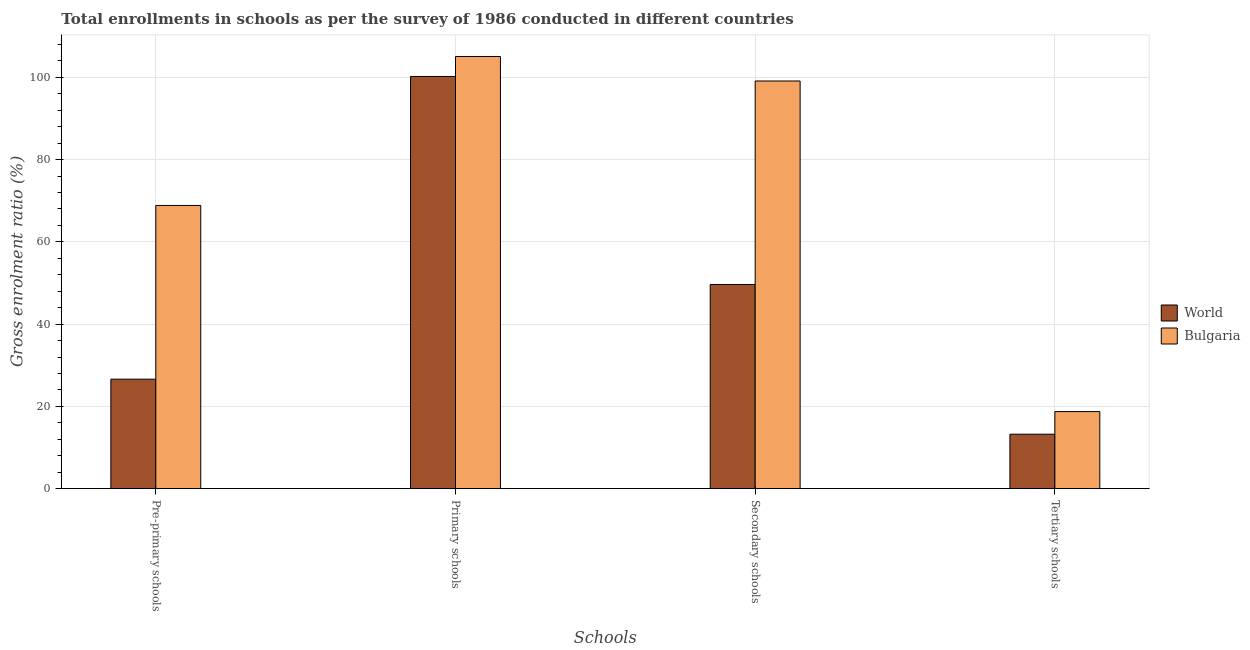How many different coloured bars are there?
Your answer should be very brief. 2. Are the number of bars per tick equal to the number of legend labels?
Provide a succinct answer. Yes. How many bars are there on the 4th tick from the right?
Your response must be concise. 2. What is the label of the 4th group of bars from the left?
Your response must be concise. Tertiary schools. What is the gross enrolment ratio in tertiary schools in World?
Ensure brevity in your answer.  13.24. Across all countries, what is the maximum gross enrolment ratio in pre-primary schools?
Give a very brief answer. 68.84. Across all countries, what is the minimum gross enrolment ratio in tertiary schools?
Make the answer very short. 13.24. In which country was the gross enrolment ratio in primary schools maximum?
Provide a short and direct response. Bulgaria. What is the total gross enrolment ratio in pre-primary schools in the graph?
Provide a short and direct response. 95.46. What is the difference between the gross enrolment ratio in primary schools in Bulgaria and that in World?
Provide a succinct answer. 4.85. What is the difference between the gross enrolment ratio in primary schools in World and the gross enrolment ratio in tertiary schools in Bulgaria?
Offer a terse response. 81.47. What is the average gross enrolment ratio in secondary schools per country?
Your answer should be compact. 74.37. What is the difference between the gross enrolment ratio in pre-primary schools and gross enrolment ratio in tertiary schools in World?
Provide a succinct answer. 13.38. In how many countries, is the gross enrolment ratio in secondary schools greater than 48 %?
Ensure brevity in your answer.  2. What is the ratio of the gross enrolment ratio in tertiary schools in Bulgaria to that in World?
Make the answer very short. 1.42. Is the gross enrolment ratio in primary schools in World less than that in Bulgaria?
Ensure brevity in your answer.  Yes. Is the difference between the gross enrolment ratio in tertiary schools in World and Bulgaria greater than the difference between the gross enrolment ratio in pre-primary schools in World and Bulgaria?
Your response must be concise. Yes. What is the difference between the highest and the second highest gross enrolment ratio in primary schools?
Ensure brevity in your answer.  4.85. What is the difference between the highest and the lowest gross enrolment ratio in primary schools?
Offer a terse response. 4.85. Is the sum of the gross enrolment ratio in tertiary schools in World and Bulgaria greater than the maximum gross enrolment ratio in pre-primary schools across all countries?
Make the answer very short. No. Is it the case that in every country, the sum of the gross enrolment ratio in pre-primary schools and gross enrolment ratio in primary schools is greater than the gross enrolment ratio in secondary schools?
Keep it short and to the point. Yes. How many bars are there?
Provide a short and direct response. 8. Does the graph contain grids?
Provide a short and direct response. Yes. How are the legend labels stacked?
Provide a succinct answer. Vertical. What is the title of the graph?
Provide a short and direct response. Total enrollments in schools as per the survey of 1986 conducted in different countries. What is the label or title of the X-axis?
Ensure brevity in your answer.  Schools. What is the label or title of the Y-axis?
Offer a very short reply. Gross enrolment ratio (%). What is the Gross enrolment ratio (%) of World in Pre-primary schools?
Make the answer very short. 26.62. What is the Gross enrolment ratio (%) of Bulgaria in Pre-primary schools?
Offer a terse response. 68.84. What is the Gross enrolment ratio (%) of World in Primary schools?
Provide a succinct answer. 100.2. What is the Gross enrolment ratio (%) in Bulgaria in Primary schools?
Your answer should be very brief. 105.06. What is the Gross enrolment ratio (%) of World in Secondary schools?
Ensure brevity in your answer.  49.64. What is the Gross enrolment ratio (%) in Bulgaria in Secondary schools?
Provide a succinct answer. 99.1. What is the Gross enrolment ratio (%) in World in Tertiary schools?
Provide a short and direct response. 13.24. What is the Gross enrolment ratio (%) in Bulgaria in Tertiary schools?
Your response must be concise. 18.74. Across all Schools, what is the maximum Gross enrolment ratio (%) of World?
Your response must be concise. 100.2. Across all Schools, what is the maximum Gross enrolment ratio (%) in Bulgaria?
Keep it short and to the point. 105.06. Across all Schools, what is the minimum Gross enrolment ratio (%) of World?
Provide a succinct answer. 13.24. Across all Schools, what is the minimum Gross enrolment ratio (%) in Bulgaria?
Your response must be concise. 18.74. What is the total Gross enrolment ratio (%) of World in the graph?
Offer a terse response. 189.7. What is the total Gross enrolment ratio (%) of Bulgaria in the graph?
Give a very brief answer. 291.74. What is the difference between the Gross enrolment ratio (%) of World in Pre-primary schools and that in Primary schools?
Your answer should be very brief. -73.58. What is the difference between the Gross enrolment ratio (%) in Bulgaria in Pre-primary schools and that in Primary schools?
Keep it short and to the point. -36.21. What is the difference between the Gross enrolment ratio (%) of World in Pre-primary schools and that in Secondary schools?
Provide a succinct answer. -23.02. What is the difference between the Gross enrolment ratio (%) in Bulgaria in Pre-primary schools and that in Secondary schools?
Give a very brief answer. -30.26. What is the difference between the Gross enrolment ratio (%) of World in Pre-primary schools and that in Tertiary schools?
Offer a very short reply. 13.38. What is the difference between the Gross enrolment ratio (%) in Bulgaria in Pre-primary schools and that in Tertiary schools?
Your response must be concise. 50.11. What is the difference between the Gross enrolment ratio (%) in World in Primary schools and that in Secondary schools?
Your answer should be compact. 50.57. What is the difference between the Gross enrolment ratio (%) of Bulgaria in Primary schools and that in Secondary schools?
Your answer should be very brief. 5.96. What is the difference between the Gross enrolment ratio (%) in World in Primary schools and that in Tertiary schools?
Your answer should be compact. 86.96. What is the difference between the Gross enrolment ratio (%) of Bulgaria in Primary schools and that in Tertiary schools?
Give a very brief answer. 86.32. What is the difference between the Gross enrolment ratio (%) of World in Secondary schools and that in Tertiary schools?
Your answer should be very brief. 36.4. What is the difference between the Gross enrolment ratio (%) in Bulgaria in Secondary schools and that in Tertiary schools?
Your answer should be very brief. 80.36. What is the difference between the Gross enrolment ratio (%) in World in Pre-primary schools and the Gross enrolment ratio (%) in Bulgaria in Primary schools?
Offer a terse response. -78.44. What is the difference between the Gross enrolment ratio (%) of World in Pre-primary schools and the Gross enrolment ratio (%) of Bulgaria in Secondary schools?
Provide a succinct answer. -72.48. What is the difference between the Gross enrolment ratio (%) in World in Pre-primary schools and the Gross enrolment ratio (%) in Bulgaria in Tertiary schools?
Provide a short and direct response. 7.88. What is the difference between the Gross enrolment ratio (%) of World in Primary schools and the Gross enrolment ratio (%) of Bulgaria in Secondary schools?
Provide a short and direct response. 1.1. What is the difference between the Gross enrolment ratio (%) of World in Primary schools and the Gross enrolment ratio (%) of Bulgaria in Tertiary schools?
Your answer should be compact. 81.47. What is the difference between the Gross enrolment ratio (%) in World in Secondary schools and the Gross enrolment ratio (%) in Bulgaria in Tertiary schools?
Offer a very short reply. 30.9. What is the average Gross enrolment ratio (%) of World per Schools?
Ensure brevity in your answer.  47.43. What is the average Gross enrolment ratio (%) of Bulgaria per Schools?
Make the answer very short. 72.94. What is the difference between the Gross enrolment ratio (%) in World and Gross enrolment ratio (%) in Bulgaria in Pre-primary schools?
Your answer should be very brief. -42.22. What is the difference between the Gross enrolment ratio (%) in World and Gross enrolment ratio (%) in Bulgaria in Primary schools?
Your answer should be compact. -4.85. What is the difference between the Gross enrolment ratio (%) in World and Gross enrolment ratio (%) in Bulgaria in Secondary schools?
Offer a very short reply. -49.46. What is the difference between the Gross enrolment ratio (%) in World and Gross enrolment ratio (%) in Bulgaria in Tertiary schools?
Offer a very short reply. -5.5. What is the ratio of the Gross enrolment ratio (%) of World in Pre-primary schools to that in Primary schools?
Make the answer very short. 0.27. What is the ratio of the Gross enrolment ratio (%) of Bulgaria in Pre-primary schools to that in Primary schools?
Provide a succinct answer. 0.66. What is the ratio of the Gross enrolment ratio (%) in World in Pre-primary schools to that in Secondary schools?
Provide a succinct answer. 0.54. What is the ratio of the Gross enrolment ratio (%) of Bulgaria in Pre-primary schools to that in Secondary schools?
Offer a very short reply. 0.69. What is the ratio of the Gross enrolment ratio (%) of World in Pre-primary schools to that in Tertiary schools?
Your response must be concise. 2.01. What is the ratio of the Gross enrolment ratio (%) of Bulgaria in Pre-primary schools to that in Tertiary schools?
Offer a very short reply. 3.67. What is the ratio of the Gross enrolment ratio (%) in World in Primary schools to that in Secondary schools?
Ensure brevity in your answer.  2.02. What is the ratio of the Gross enrolment ratio (%) of Bulgaria in Primary schools to that in Secondary schools?
Make the answer very short. 1.06. What is the ratio of the Gross enrolment ratio (%) of World in Primary schools to that in Tertiary schools?
Provide a short and direct response. 7.57. What is the ratio of the Gross enrolment ratio (%) in Bulgaria in Primary schools to that in Tertiary schools?
Ensure brevity in your answer.  5.61. What is the ratio of the Gross enrolment ratio (%) in World in Secondary schools to that in Tertiary schools?
Provide a succinct answer. 3.75. What is the ratio of the Gross enrolment ratio (%) in Bulgaria in Secondary schools to that in Tertiary schools?
Keep it short and to the point. 5.29. What is the difference between the highest and the second highest Gross enrolment ratio (%) of World?
Ensure brevity in your answer.  50.57. What is the difference between the highest and the second highest Gross enrolment ratio (%) of Bulgaria?
Provide a short and direct response. 5.96. What is the difference between the highest and the lowest Gross enrolment ratio (%) in World?
Your answer should be compact. 86.96. What is the difference between the highest and the lowest Gross enrolment ratio (%) of Bulgaria?
Make the answer very short. 86.32. 